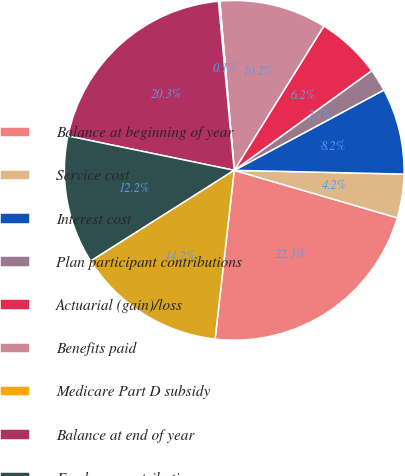<chart> <loc_0><loc_0><loc_500><loc_500><pie_chart><fcel>Balance at beginning of year<fcel>Service cost<fcel>Interest cost<fcel>Plan participant contributions<fcel>Actuarial (gain)/loss<fcel>Benefits paid<fcel>Medicare Part D subsidy<fcel>Balance at end of year<fcel>Employer contributions<fcel>Funded status<nl><fcel>22.29%<fcel>4.16%<fcel>8.19%<fcel>2.15%<fcel>6.17%<fcel>10.2%<fcel>0.13%<fcel>20.27%<fcel>12.22%<fcel>14.23%<nl></chart> 